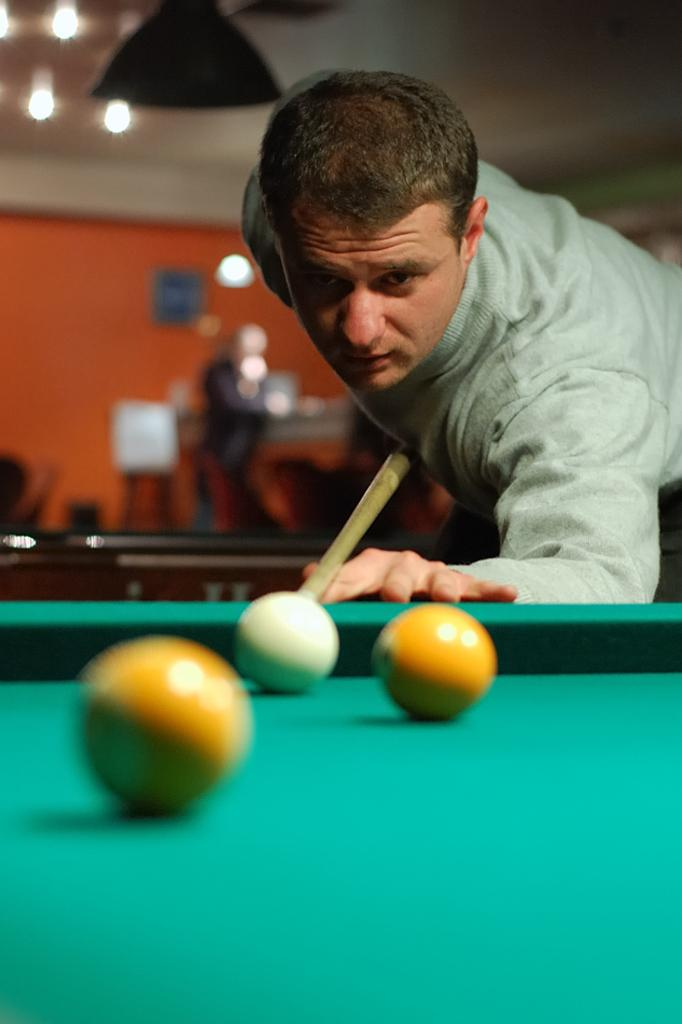What is the main subject of the image? There is a man in the image. What activity is the man engaged in? The man is playing billiards. Where is the brush used for painting in the image? There is no brush present in the image. What type of books can be found in the library depicted in the image? There is no library depicted in the image. 